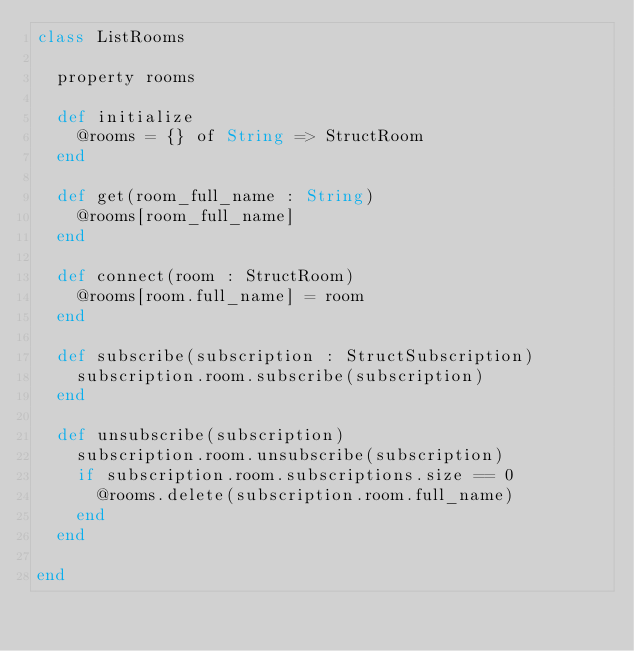<code> <loc_0><loc_0><loc_500><loc_500><_Crystal_>class ListRooms

  property rooms

  def initialize
    @rooms = {} of String => StructRoom
  end

  def get(room_full_name : String)
    @rooms[room_full_name]
  end

  def connect(room : StructRoom)
    @rooms[room.full_name] = room
  end

  def subscribe(subscription : StructSubscription)
    subscription.room.subscribe(subscription)
  end

  def unsubscribe(subscription)
    subscription.room.unsubscribe(subscription)
    if subscription.room.subscriptions.size == 0
      @rooms.delete(subscription.room.full_name)
    end
  end

end</code> 